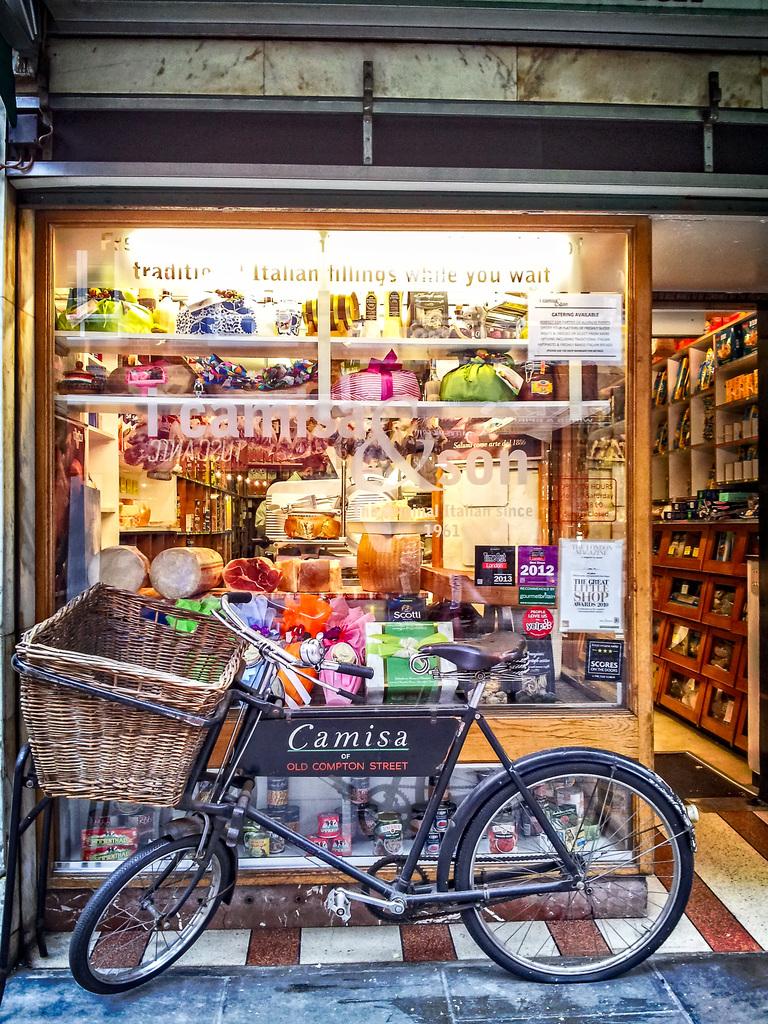What does the bike say?
Make the answer very short. Camisa. 